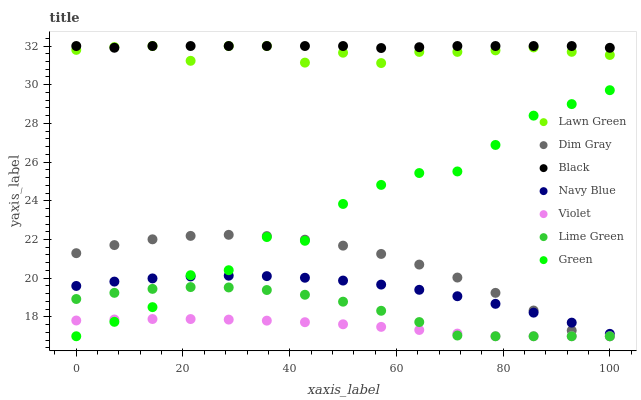Does Violet have the minimum area under the curve?
Answer yes or no. Yes. Does Black have the maximum area under the curve?
Answer yes or no. Yes. Does Dim Gray have the minimum area under the curve?
Answer yes or no. No. Does Dim Gray have the maximum area under the curve?
Answer yes or no. No. Is Violet the smoothest?
Answer yes or no. Yes. Is Green the roughest?
Answer yes or no. Yes. Is Dim Gray the smoothest?
Answer yes or no. No. Is Dim Gray the roughest?
Answer yes or no. No. Does Dim Gray have the lowest value?
Answer yes or no. Yes. Does Navy Blue have the lowest value?
Answer yes or no. No. Does Black have the highest value?
Answer yes or no. Yes. Does Dim Gray have the highest value?
Answer yes or no. No. Is Dim Gray less than Black?
Answer yes or no. Yes. Is Black greater than Dim Gray?
Answer yes or no. Yes. Does Green intersect Navy Blue?
Answer yes or no. Yes. Is Green less than Navy Blue?
Answer yes or no. No. Is Green greater than Navy Blue?
Answer yes or no. No. Does Dim Gray intersect Black?
Answer yes or no. No. 